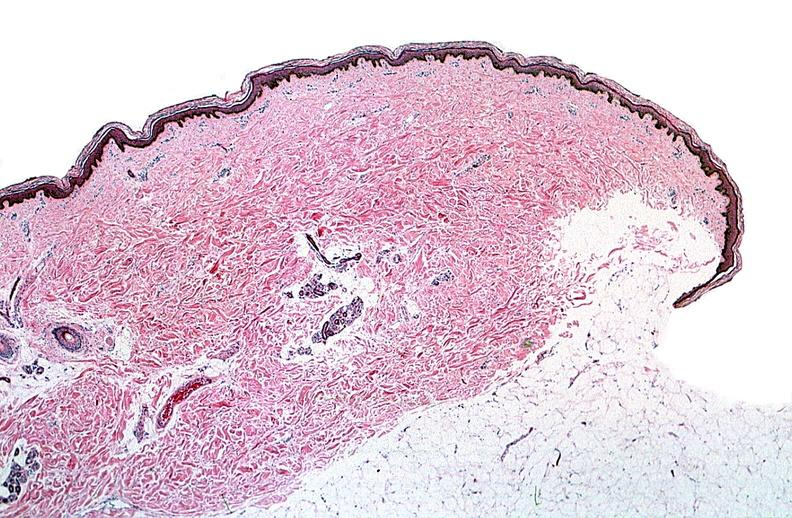does this image show thermal burned skin?
Answer the question using a single word or phrase. Yes 